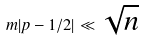Convert formula to latex. <formula><loc_0><loc_0><loc_500><loc_500>m | p - 1 / 2 | \ll \sqrt { n }</formula> 